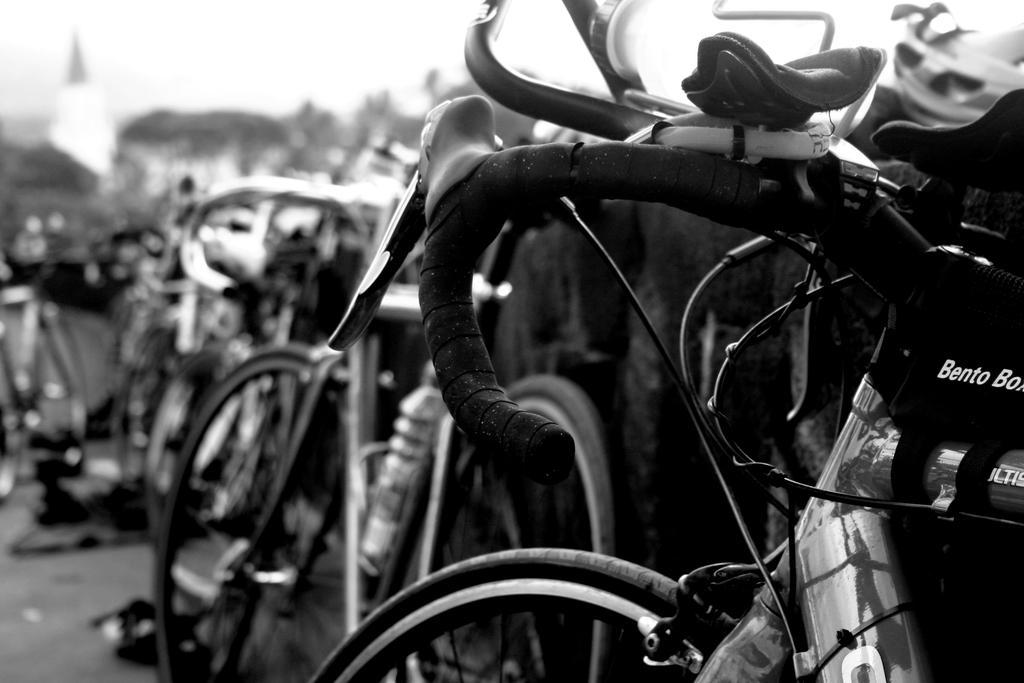How would you summarize this image in a sentence or two? This picture shows few bicycles parked on the side and we see a house and a cloudy sky and we see water bottle in the holder. 